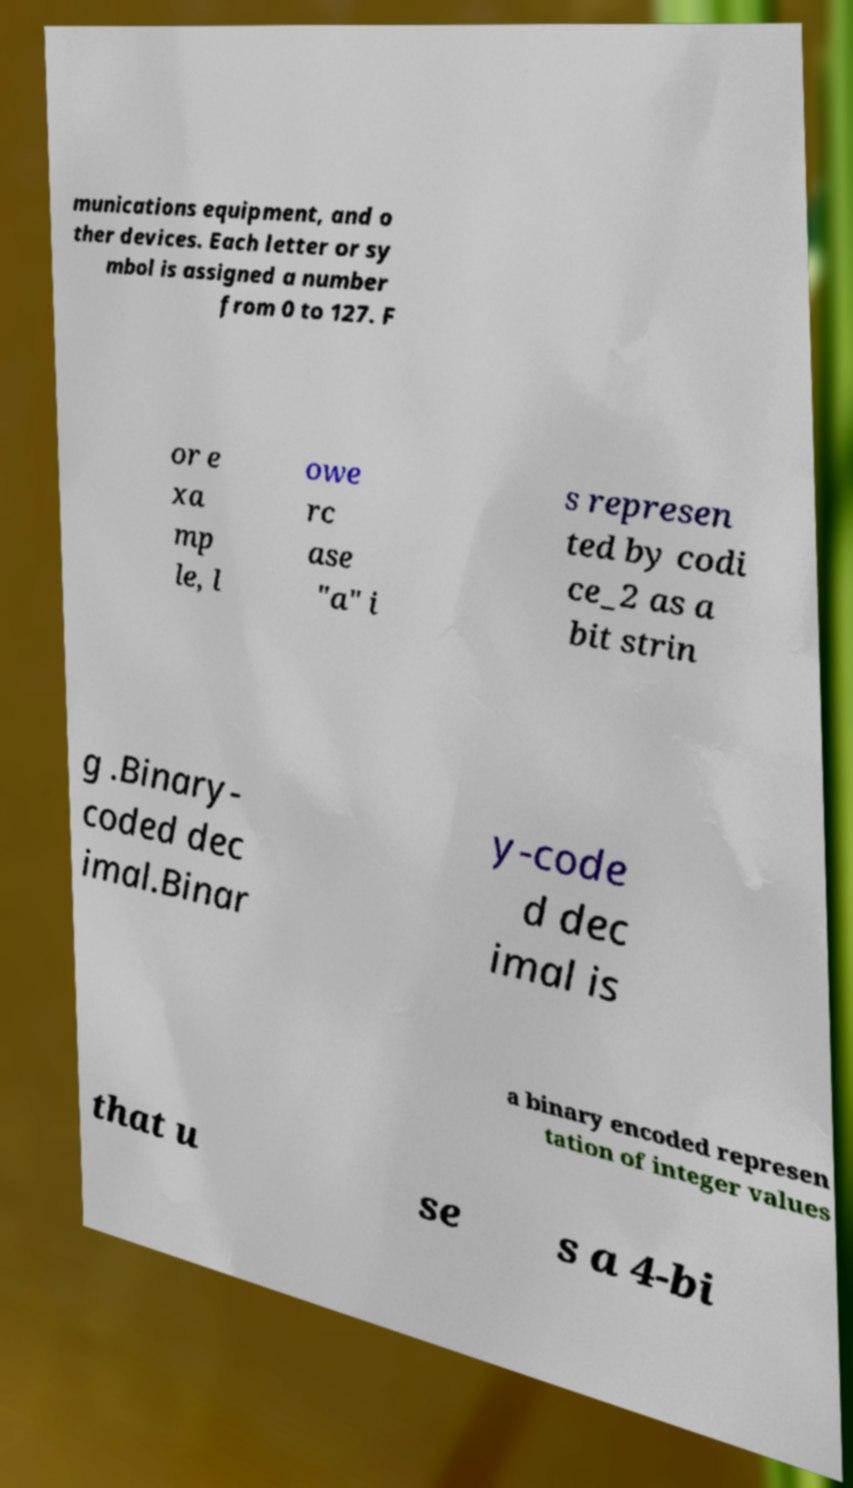Can you accurately transcribe the text from the provided image for me? munications equipment, and o ther devices. Each letter or sy mbol is assigned a number from 0 to 127. F or e xa mp le, l owe rc ase "a" i s represen ted by codi ce_2 as a bit strin g .Binary- coded dec imal.Binar y-code d dec imal is a binary encoded represen tation of integer values that u se s a 4-bi 